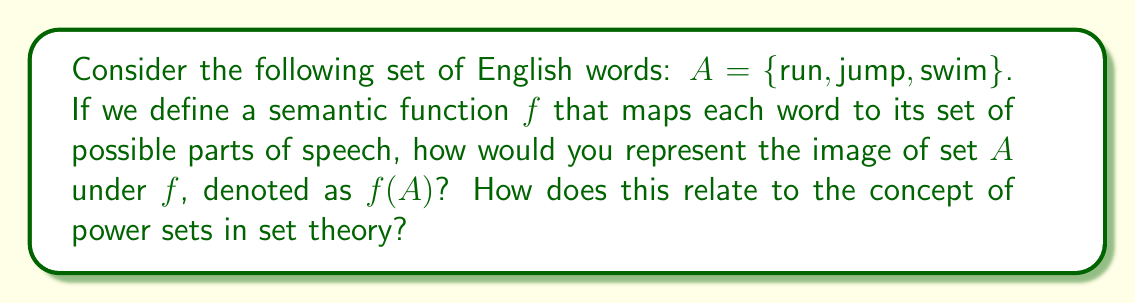Teach me how to tackle this problem. To solve this problem, let's approach it step-by-step:

1) First, we need to understand what parts of speech each word in set $A$ can be:
   - "run" can be a verb or a noun
   - "jump" can be a verb or a noun
   - "swim" can be a verb

2) Let's define the set of possible parts of speech as $P = \{\text{verb}, \text{noun}\}$

3) Now, we can define our semantic function $f$ as:
   $f(\text{run}) = \{\text{verb}, \text{noun}\}$
   $f(\text{jump}) = \{\text{verb}, \text{noun}\}$
   $f(\text{swim}) = \{\text{verb}\}$

4) The image of set $A$ under $f$, denoted as $f(A)$, is the set of all distinct outputs of $f$ for elements in $A$:
   $f(A) = \{\{\text{verb}, \text{noun}\}, \{\text{verb}\}\}$

5) Now, let's consider how this relates to power sets. The power set of a set $S$, denoted $\mathcal{P}(S)$, is the set of all subsets of $S$, including the empty set and $S$ itself.

6) In our case, if we take the power set of $P$:
   $\mathcal{P}(P) = \{\emptyset, \{\text{verb}\}, \{\text{noun}\}, \{\text{verb}, \text{noun}\}\}$

7) We can observe that $f(A)$ is a subset of $\mathcal{P}(P)$. In fact, $f(A) \subseteq \mathcal{P}(P) \setminus \{\emptyset\}$

This relationship demonstrates how set theory concepts like power sets can be applied to linguistic semantics. The power set of possible parts of speech represents all possible combinations of parts of speech a word could have, and our semantic function maps words to elements of this power set.
Answer: $f(A) = \{\{\text{verb}, \text{noun}\}, \{\text{verb}\}\}$

The image of set $A$ under $f$ is a subset of the power set of $P$ (excluding the empty set): $f(A) \subseteq \mathcal{P}(P) \setminus \{\emptyset\}$ 